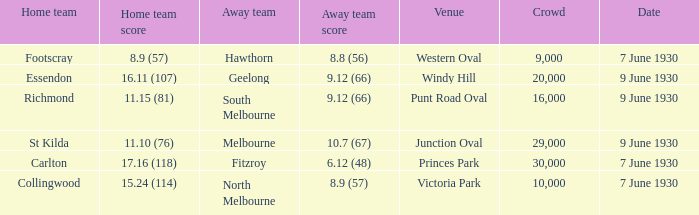Could you help me parse every detail presented in this table? {'header': ['Home team', 'Home team score', 'Away team', 'Away team score', 'Venue', 'Crowd', 'Date'], 'rows': [['Footscray', '8.9 (57)', 'Hawthorn', '8.8 (56)', 'Western Oval', '9,000', '7 June 1930'], ['Essendon', '16.11 (107)', 'Geelong', '9.12 (66)', 'Windy Hill', '20,000', '9 June 1930'], ['Richmond', '11.15 (81)', 'South Melbourne', '9.12 (66)', 'Punt Road Oval', '16,000', '9 June 1930'], ['St Kilda', '11.10 (76)', 'Melbourne', '10.7 (67)', 'Junction Oval', '29,000', '9 June 1930'], ['Carlton', '17.16 (118)', 'Fitzroy', '6.12 (48)', 'Princes Park', '30,000', '7 June 1930'], ['Collingwood', '15.24 (114)', 'North Melbourne', '8.9 (57)', 'Victoria Park', '10,000', '7 June 1930']]} Where did the away team score 8.9 (57)? Victoria Park. 